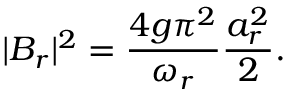Convert formula to latex. <formula><loc_0><loc_0><loc_500><loc_500>| B _ { r } | ^ { 2 } = \frac { 4 g \pi ^ { 2 } } { \omega _ { r } } \frac { a _ { r } ^ { 2 } } { 2 } .</formula> 